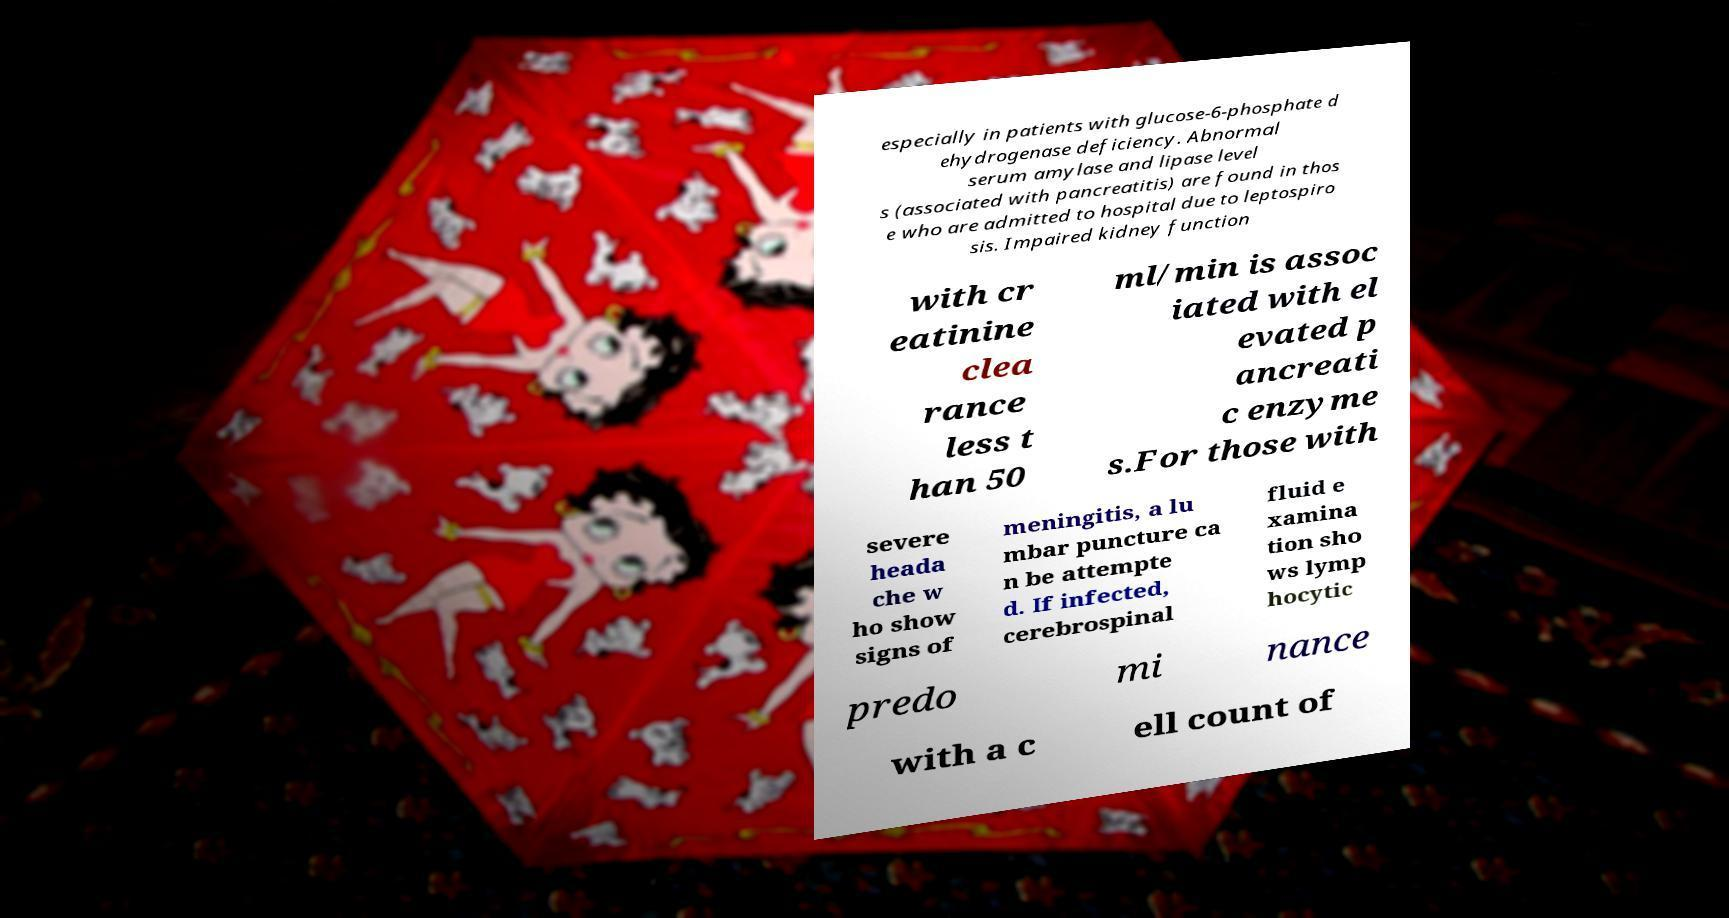Can you read and provide the text displayed in the image?This photo seems to have some interesting text. Can you extract and type it out for me? especially in patients with glucose-6-phosphate d ehydrogenase deficiency. Abnormal serum amylase and lipase level s (associated with pancreatitis) are found in thos e who are admitted to hospital due to leptospiro sis. Impaired kidney function with cr eatinine clea rance less t han 50 ml/min is assoc iated with el evated p ancreati c enzyme s.For those with severe heada che w ho show signs of meningitis, a lu mbar puncture ca n be attempte d. If infected, cerebrospinal fluid e xamina tion sho ws lymp hocytic predo mi nance with a c ell count of 